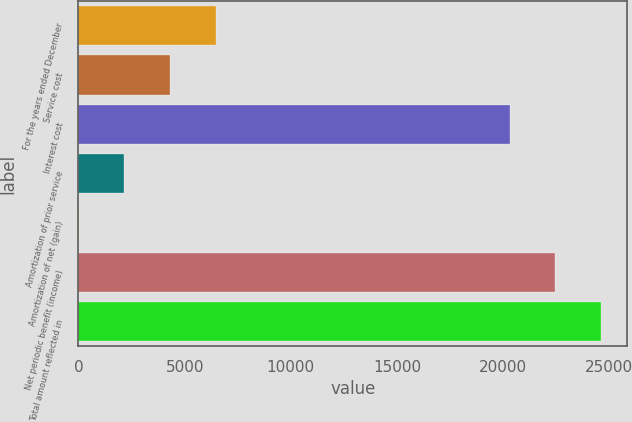Convert chart. <chart><loc_0><loc_0><loc_500><loc_500><bar_chart><fcel>For the years ended December<fcel>Service cost<fcel>Interest cost<fcel>Amortization of prior service<fcel>Amortization of net (gain)<fcel>Net periodic benefit (income)<fcel>Total amount reflected in<nl><fcel>6479.1<fcel>4320.4<fcel>20299<fcel>2161.7<fcel>3<fcel>22457.7<fcel>24616.4<nl></chart> 